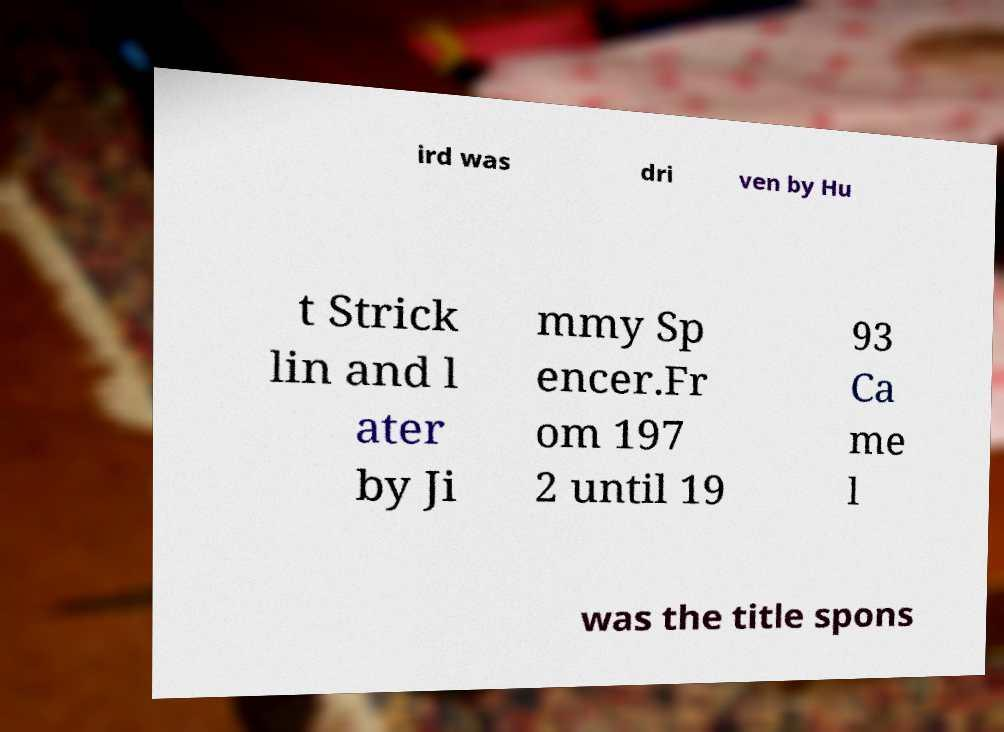Can you accurately transcribe the text from the provided image for me? ird was dri ven by Hu t Strick lin and l ater by Ji mmy Sp encer.Fr om 197 2 until 19 93 Ca me l was the title spons 